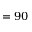Convert formula to latex. <formula><loc_0><loc_0><loc_500><loc_500>= 9 0</formula> 